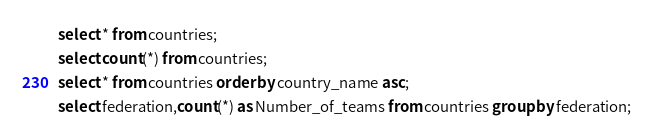<code> <loc_0><loc_0><loc_500><loc_500><_SQL_>select * from countries;
select count(*) from countries;
select * from countries order by country_name asc;
select federation,count(*) as Number_of_teams from countries group by federation;</code> 